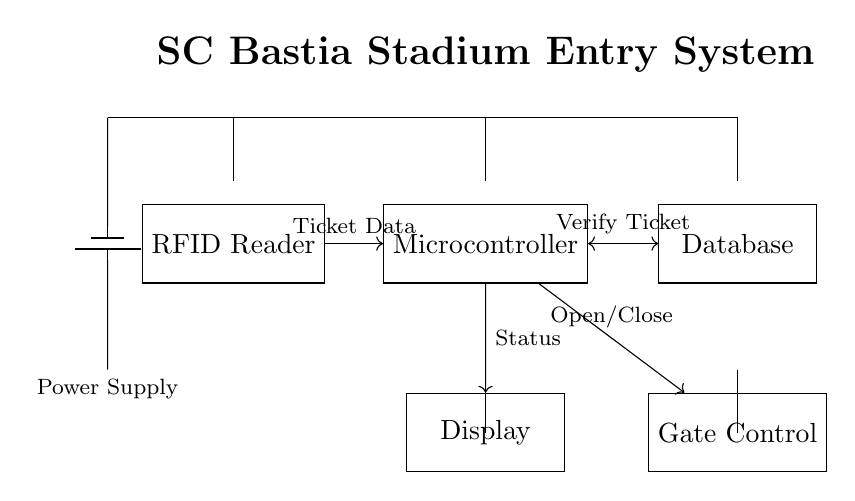What components are included in this circuit? The components in this circuit are an RFID Reader, Microcontroller, Database, Display, and Gate Control. Each of these is represented as a labeled rectangular block in the diagram.
Answer: RFID Reader, Microcontroller, Database, Display, Gate Control What is the purpose of the Microcontroller in the circuit? The Microcontroller processes the ticket data received from the RFID Reader, verifies it against the Database, sends status to the Display, and controls the Gate. It acts as the central processing unit for the system.
Answer: Process tickets and control Gate How does the power supply connect to the circuit? The power supply is depicted as a battery and connects to the top of all components in the circuit through horizontal lines, providing electrical energy to each component.
Answer: Through horizontal lines How is the ticket verification process executed? The process begins with the RFID Reader sending ticket data to the Microcontroller, which then verifies the data with the Database. If verified, it relays the status to the Display and sends a command to the Gate Control to open.
Answer: Reader to MCU to Database to Display and Gate What type of digital system is this circuit designed for? This circuit is designed specifically for an electronic ticketing system, which uses RFID technology to verify entry at a stadium or similar venue.
Answer: Electronic ticketing system What does the connection from the Microcontroller to the Gate Control indicate? The connection signifies that the Microcontroller sends signals (Open/Close) to the Gate Control based on the ticket verification outcome. It enables or restricts access to the venue depending on the ticket status.
Answer: Open/Close access 